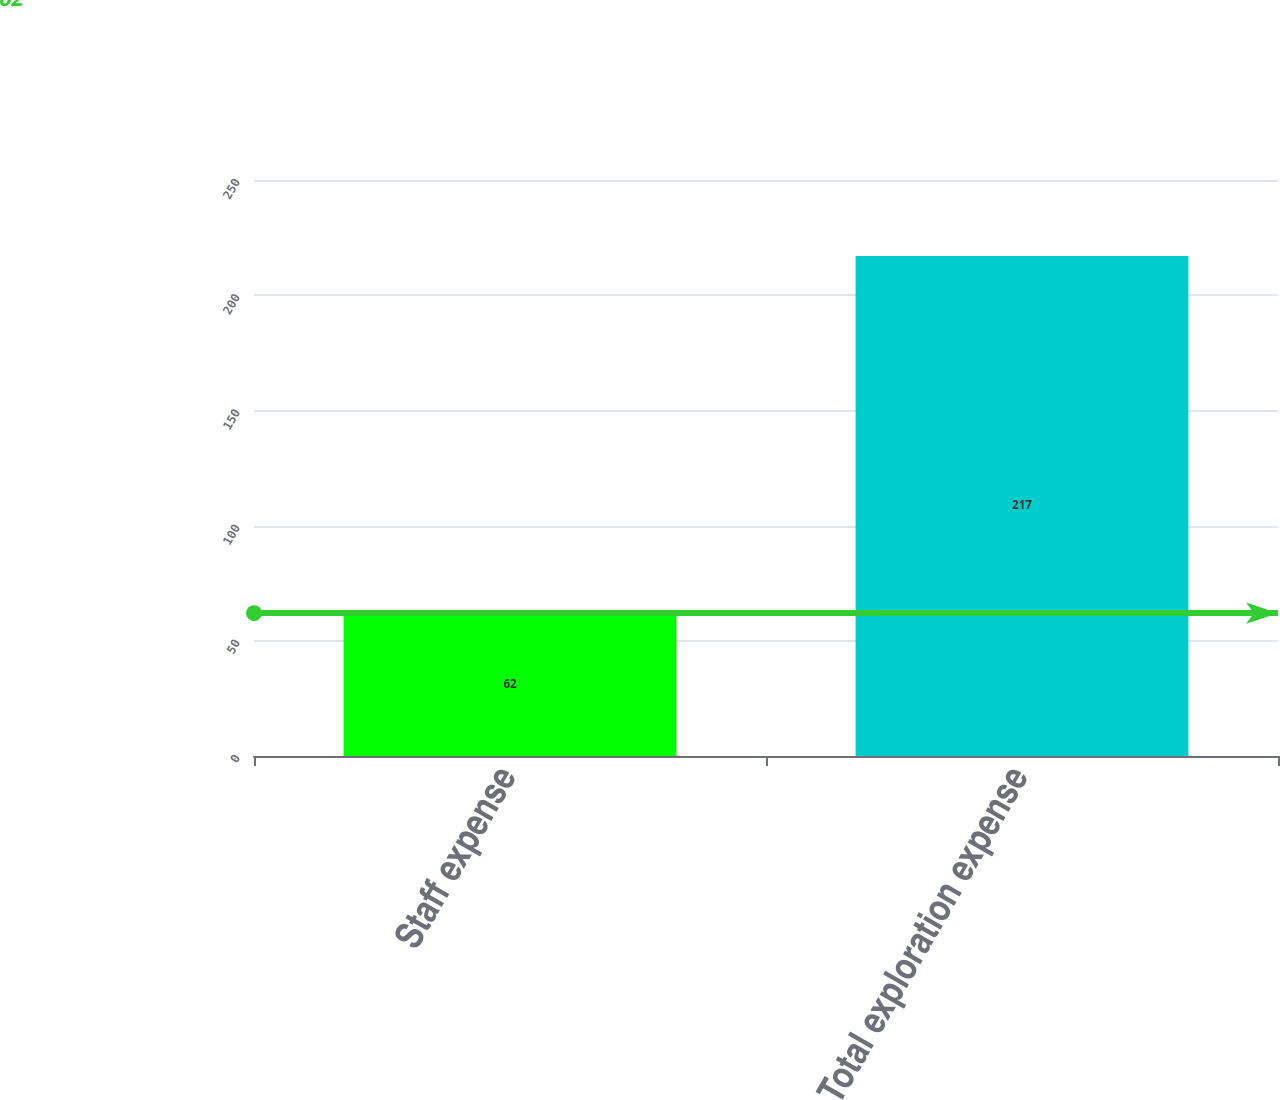<chart> <loc_0><loc_0><loc_500><loc_500><bar_chart><fcel>Staff expense<fcel>Total exploration expense<nl><fcel>62<fcel>217<nl></chart> 